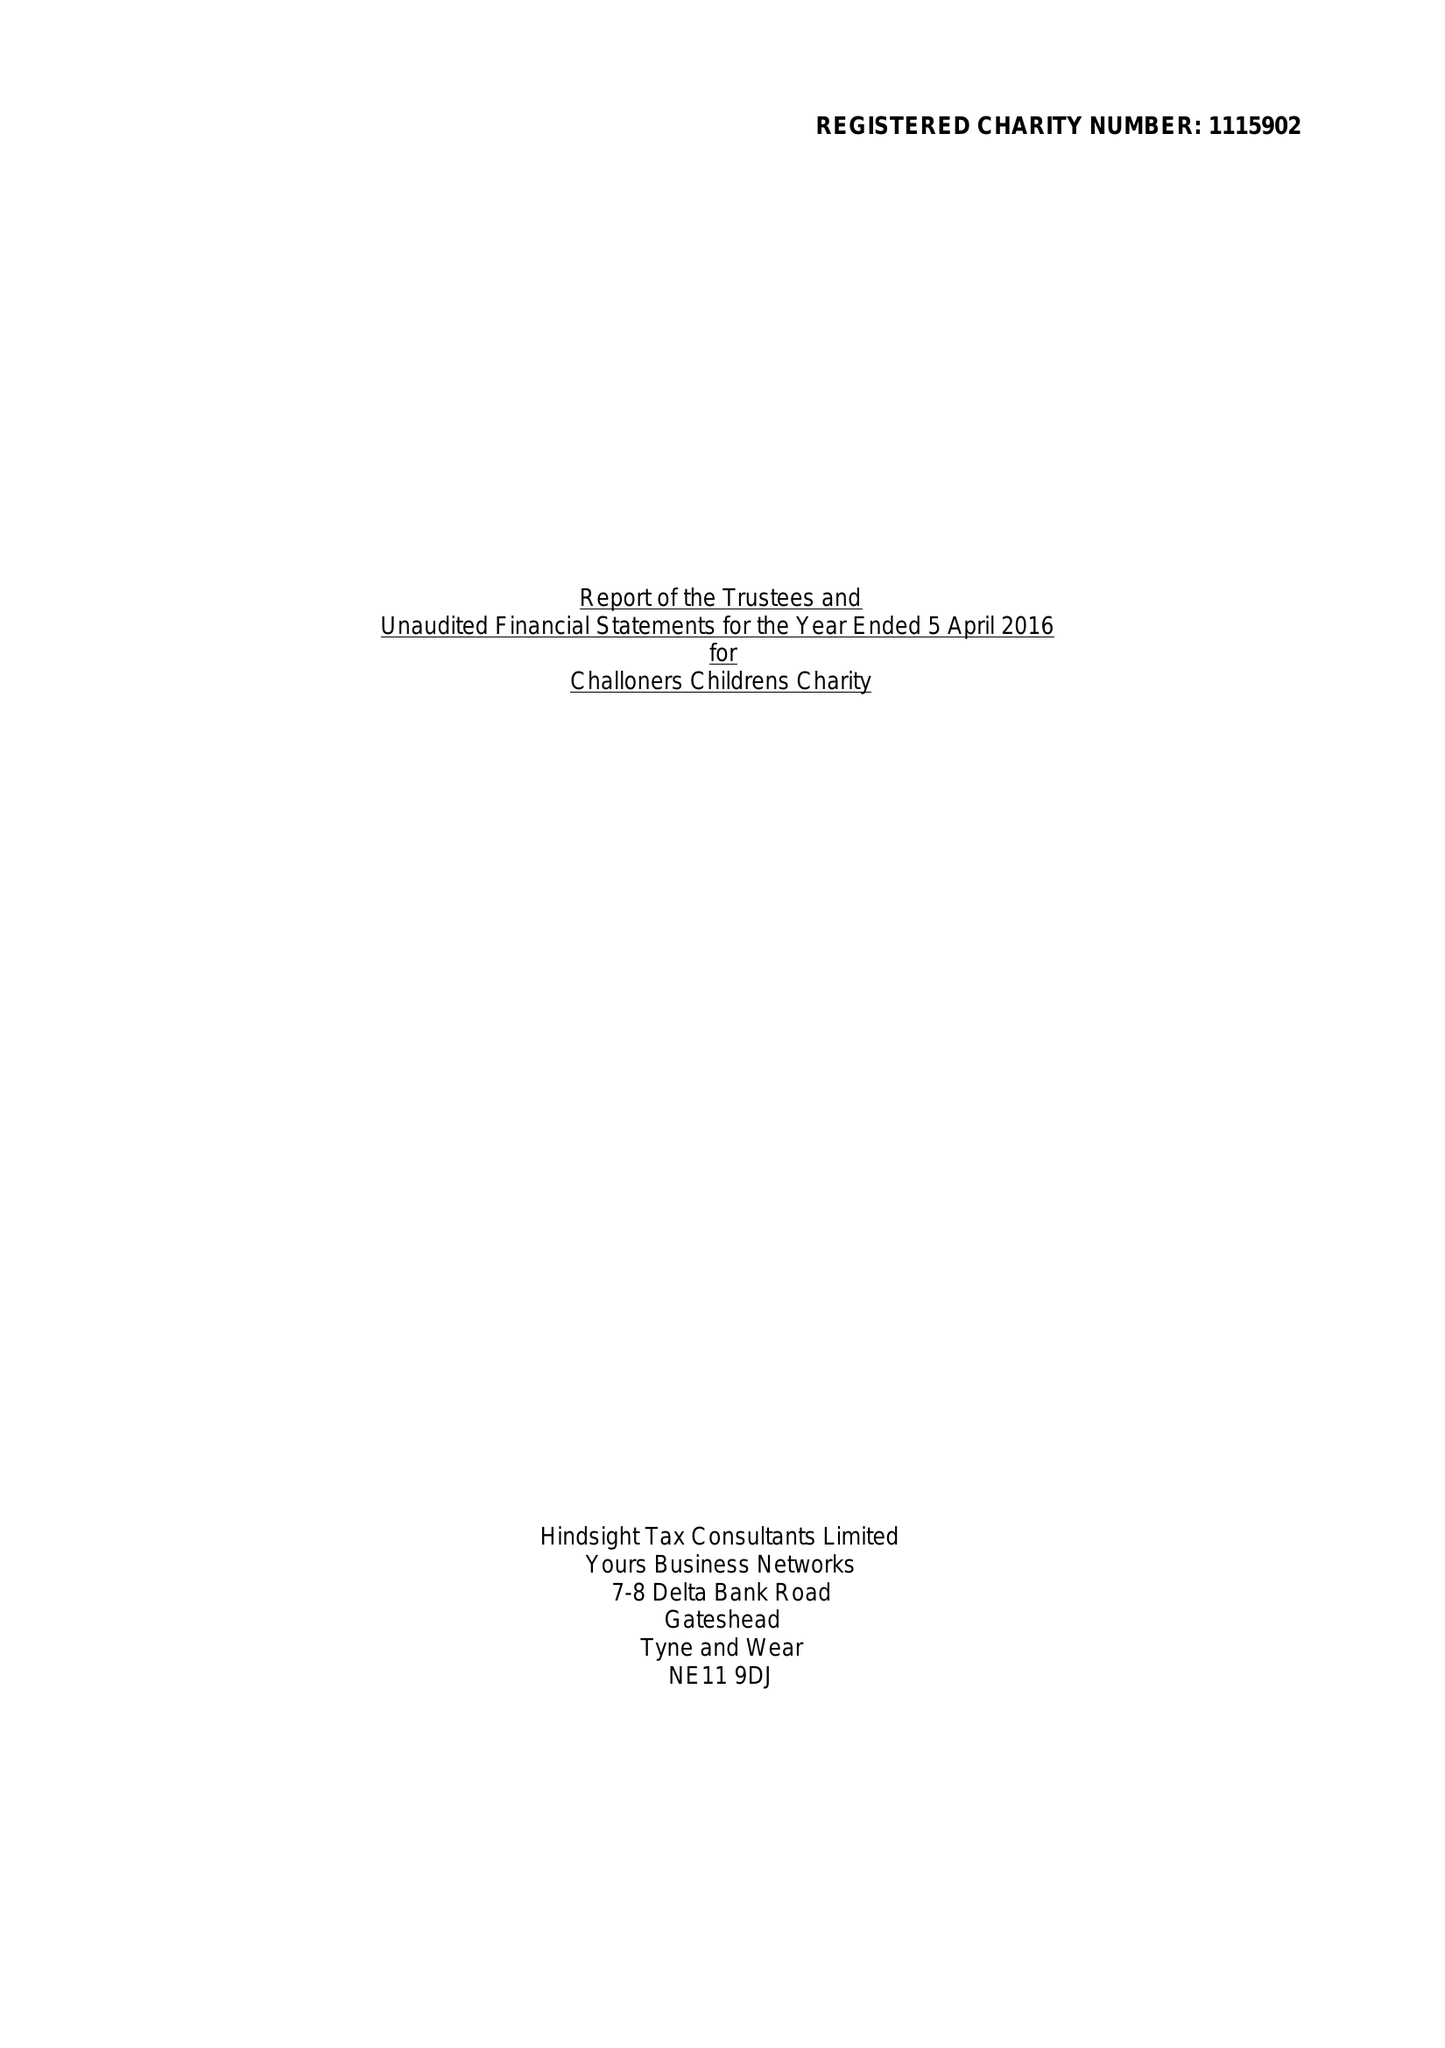What is the value for the report_date?
Answer the question using a single word or phrase. 2016-04-05 